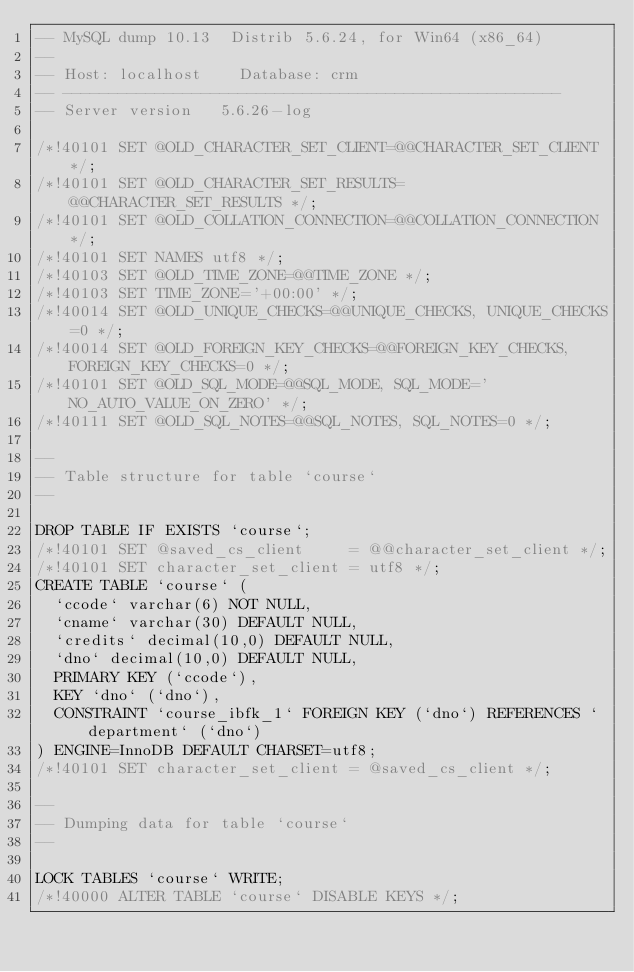<code> <loc_0><loc_0><loc_500><loc_500><_SQL_>-- MySQL dump 10.13  Distrib 5.6.24, for Win64 (x86_64)
--
-- Host: localhost    Database: crm
-- ------------------------------------------------------
-- Server version	5.6.26-log

/*!40101 SET @OLD_CHARACTER_SET_CLIENT=@@CHARACTER_SET_CLIENT */;
/*!40101 SET @OLD_CHARACTER_SET_RESULTS=@@CHARACTER_SET_RESULTS */;
/*!40101 SET @OLD_COLLATION_CONNECTION=@@COLLATION_CONNECTION */;
/*!40101 SET NAMES utf8 */;
/*!40103 SET @OLD_TIME_ZONE=@@TIME_ZONE */;
/*!40103 SET TIME_ZONE='+00:00' */;
/*!40014 SET @OLD_UNIQUE_CHECKS=@@UNIQUE_CHECKS, UNIQUE_CHECKS=0 */;
/*!40014 SET @OLD_FOREIGN_KEY_CHECKS=@@FOREIGN_KEY_CHECKS, FOREIGN_KEY_CHECKS=0 */;
/*!40101 SET @OLD_SQL_MODE=@@SQL_MODE, SQL_MODE='NO_AUTO_VALUE_ON_ZERO' */;
/*!40111 SET @OLD_SQL_NOTES=@@SQL_NOTES, SQL_NOTES=0 */;

--
-- Table structure for table `course`
--

DROP TABLE IF EXISTS `course`;
/*!40101 SET @saved_cs_client     = @@character_set_client */;
/*!40101 SET character_set_client = utf8 */;
CREATE TABLE `course` (
  `ccode` varchar(6) NOT NULL,
  `cname` varchar(30) DEFAULT NULL,
  `credits` decimal(10,0) DEFAULT NULL,
  `dno` decimal(10,0) DEFAULT NULL,
  PRIMARY KEY (`ccode`),
  KEY `dno` (`dno`),
  CONSTRAINT `course_ibfk_1` FOREIGN KEY (`dno`) REFERENCES `department` (`dno`)
) ENGINE=InnoDB DEFAULT CHARSET=utf8;
/*!40101 SET character_set_client = @saved_cs_client */;

--
-- Dumping data for table `course`
--

LOCK TABLES `course` WRITE;
/*!40000 ALTER TABLE `course` DISABLE KEYS */;</code> 